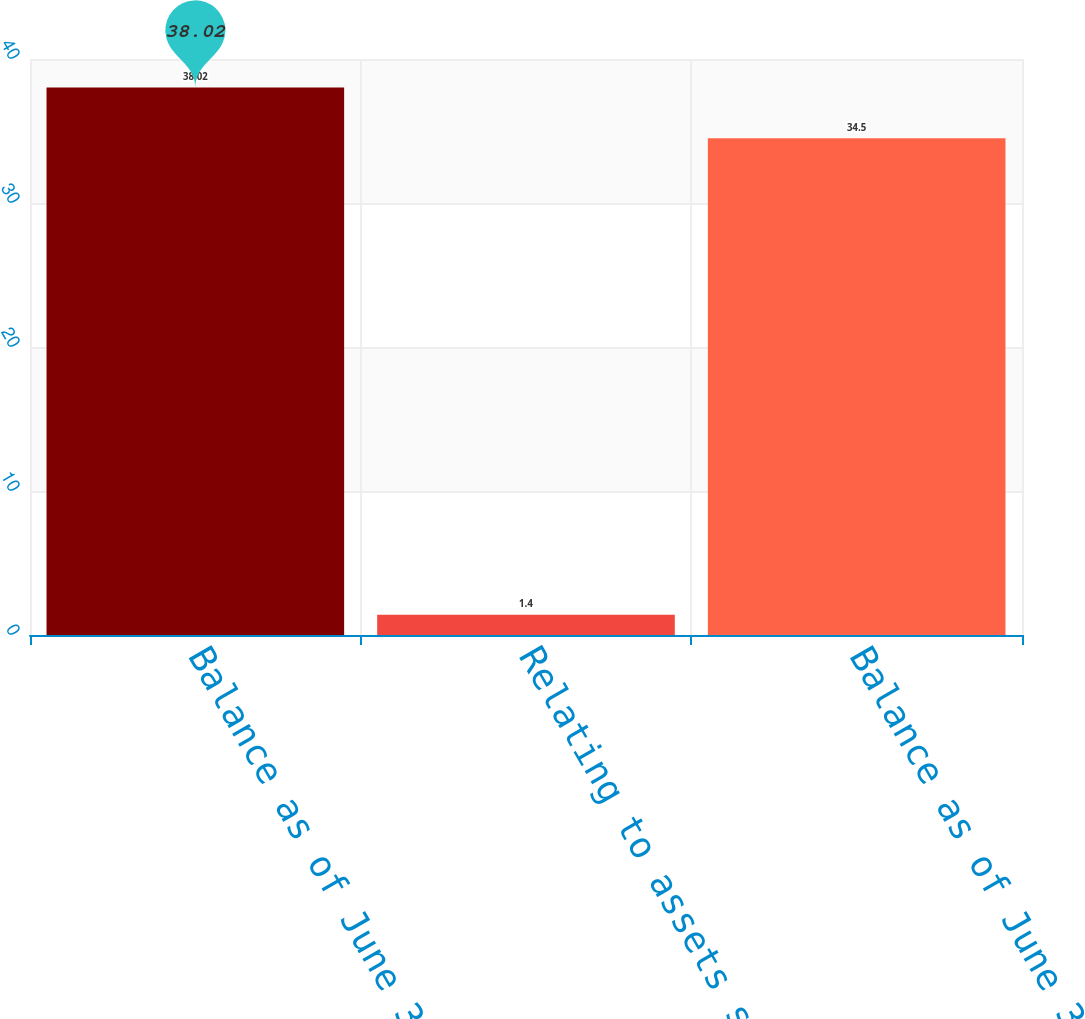Convert chart. <chart><loc_0><loc_0><loc_500><loc_500><bar_chart><fcel>Balance as of June 30 2013<fcel>Relating to assets still held<fcel>Balance as of June 30 2014<nl><fcel>38.02<fcel>1.4<fcel>34.5<nl></chart> 